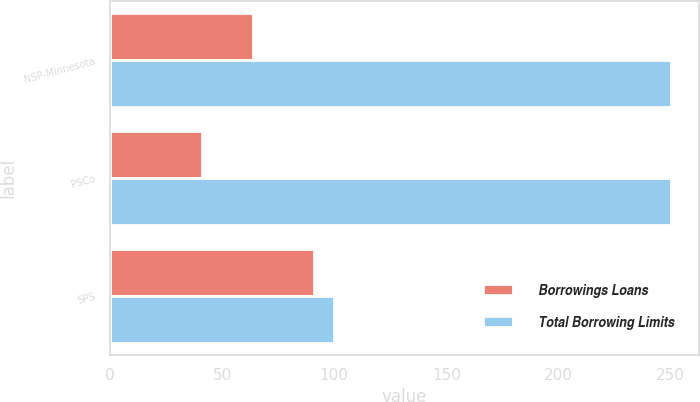<chart> <loc_0><loc_0><loc_500><loc_500><stacked_bar_chart><ecel><fcel>NSP-Minnesota<fcel>PSCo<fcel>SPS<nl><fcel>Borrowings Loans<fcel>64<fcel>41<fcel>91<nl><fcel>Total Borrowing Limits<fcel>250<fcel>250<fcel>100<nl></chart> 